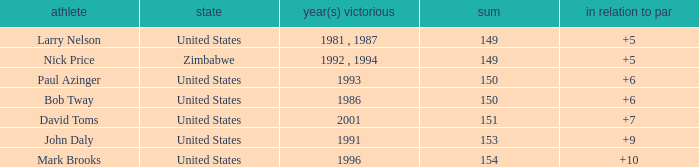How many to pars were won in 1993? 1.0. 